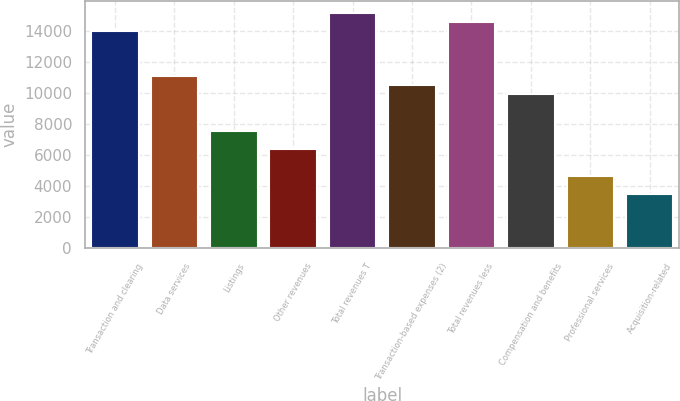Convert chart to OTSL. <chart><loc_0><loc_0><loc_500><loc_500><bar_chart><fcel>Transaction and clearing<fcel>Data services<fcel>Listings<fcel>Other revenues<fcel>Total revenues T<fcel>Transaction-based expenses (2)<fcel>Total revenues less<fcel>Compensation and benefits<fcel>Professional services<fcel>Acquisition-related<nl><fcel>14022.1<fcel>11101<fcel>7595.66<fcel>6427.22<fcel>15190.5<fcel>10516.8<fcel>14606.3<fcel>9932.54<fcel>4674.56<fcel>3506.12<nl></chart> 